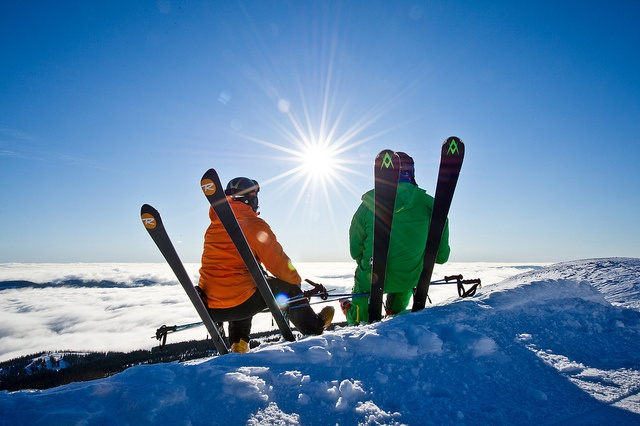Describe the objects in this image and their specific colors. I can see people in darkblue, black, brown, and maroon tones, people in darkblue, darkgreen, black, and teal tones, skis in darkblue, black, darkgreen, gray, and purple tones, and skis in darkblue, black, maroon, gray, and brown tones in this image. 